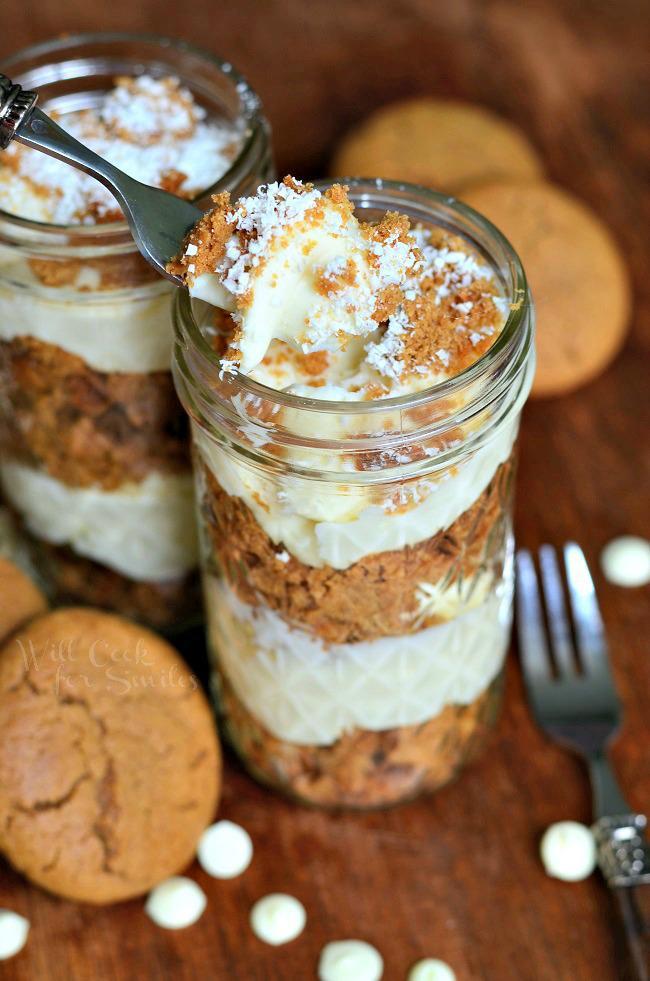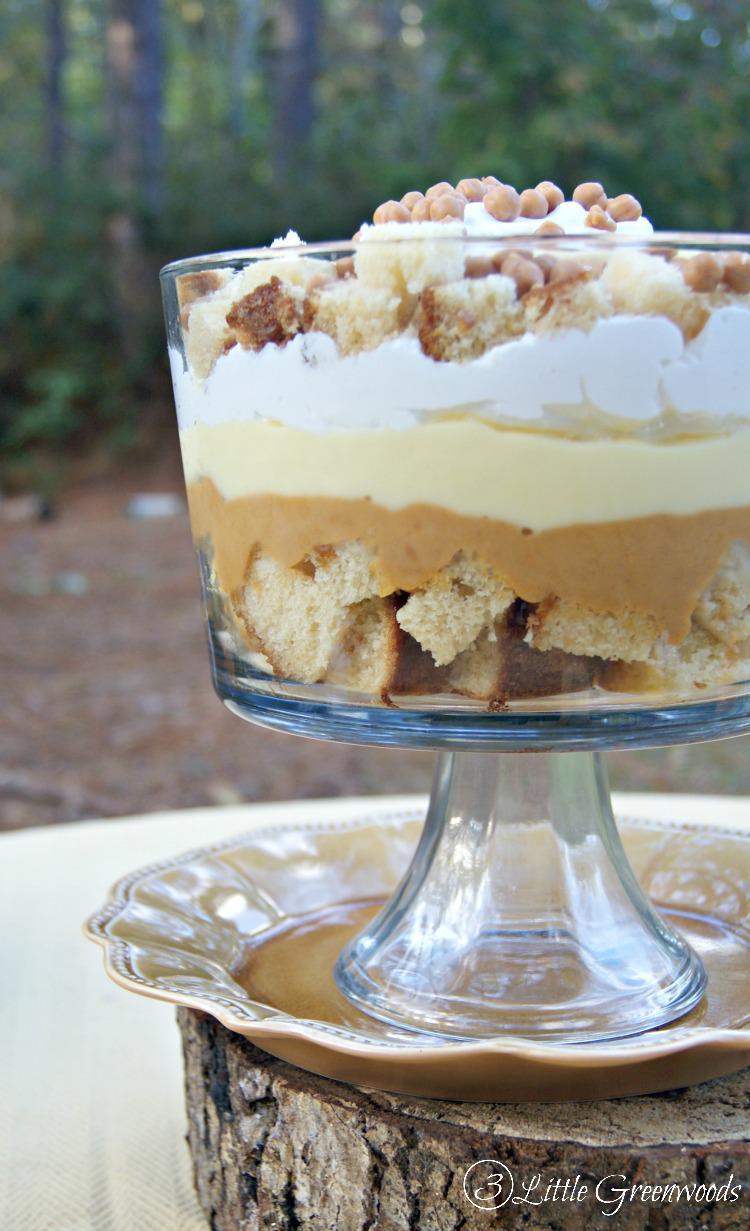The first image is the image on the left, the second image is the image on the right. Assess this claim about the two images: "There are four glasses of a whipped cream topped dessert in one of the images.". Correct or not? Answer yes or no. No. The first image is the image on the left, the second image is the image on the right. Given the left and right images, does the statement "All of the desserts shown have some type of fruit on top." hold true? Answer yes or no. No. 